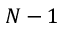<formula> <loc_0><loc_0><loc_500><loc_500>N - 1</formula> 